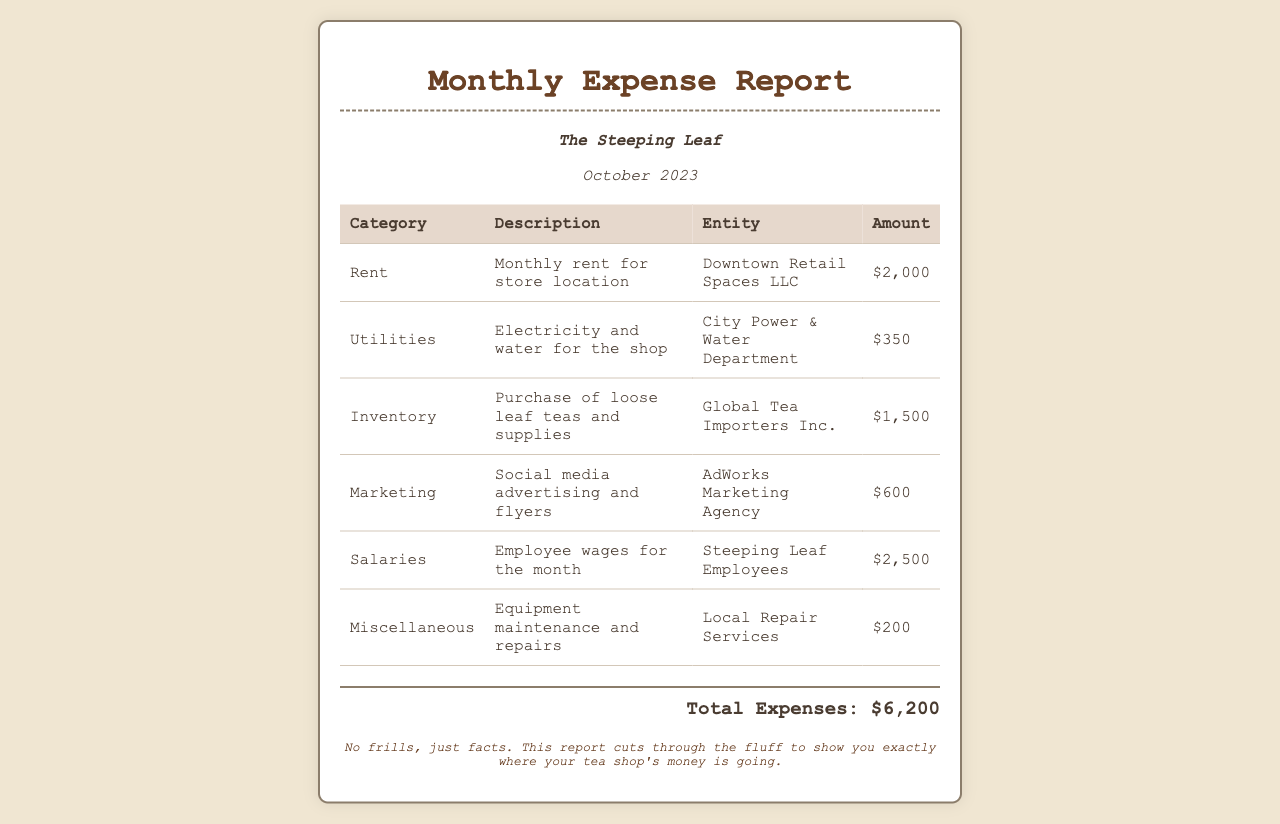What is the total amount spent on salaries? The amount for salaries is given in the table, which is $2,500.
Answer: $2,500 Who is responsible for the monthly rent? The entity responsible for rent is listed in the document as Downtown Retail Spaces LLC.
Answer: Downtown Retail Spaces LLC What is the expense for marketing activities? The expense for marketing is outlined in the report as $600.
Answer: $600 How much was spent on utilities? The amount listed for utilities, specifically electricity and water, is $350.
Answer: $350 What category does equipment maintenance fall under? The document classifies equipment maintenance expenses under the category Miscellaneous.
Answer: Miscellaneous What was the total sum of all expenses? The total of all expenses is clearly stated at the bottom of the report, which is $6,200.
Answer: $6,200 What was the main purpose of the Marketing expense? The document specifies that the marketing expense relates to social media advertising and flyers.
Answer: Social media advertising and flyers Which company provided the inventory? The entity for inventory purchases is stated as Global Tea Importers Inc. in the document.
Answer: Global Tea Importers Inc What month does this report cover? The report clearly indicates it covers the month of October 2023.
Answer: October 2023 